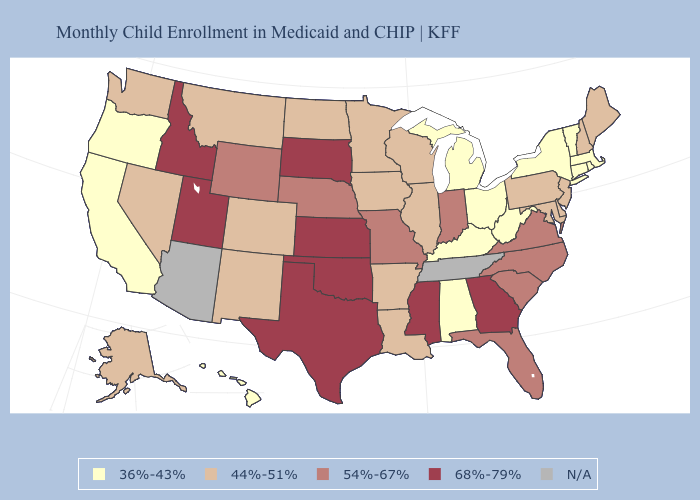Does Nevada have the lowest value in the West?
Write a very short answer. No. Which states hav the highest value in the Northeast?
Quick response, please. Maine, New Hampshire, New Jersey, Pennsylvania. Does the map have missing data?
Be succinct. Yes. What is the value of Connecticut?
Concise answer only. 36%-43%. How many symbols are there in the legend?
Concise answer only. 5. What is the lowest value in the Northeast?
Short answer required. 36%-43%. Name the states that have a value in the range 68%-79%?
Concise answer only. Georgia, Idaho, Kansas, Mississippi, Oklahoma, South Dakota, Texas, Utah. What is the lowest value in the Northeast?
Quick response, please. 36%-43%. What is the highest value in the West ?
Concise answer only. 68%-79%. What is the value of New York?
Give a very brief answer. 36%-43%. What is the value of Wisconsin?
Be succinct. 44%-51%. Among the states that border Oklahoma , does Colorado have the highest value?
Answer briefly. No. Among the states that border Iowa , does South Dakota have the highest value?
Short answer required. Yes. Does Missouri have the highest value in the MidWest?
Write a very short answer. No. 